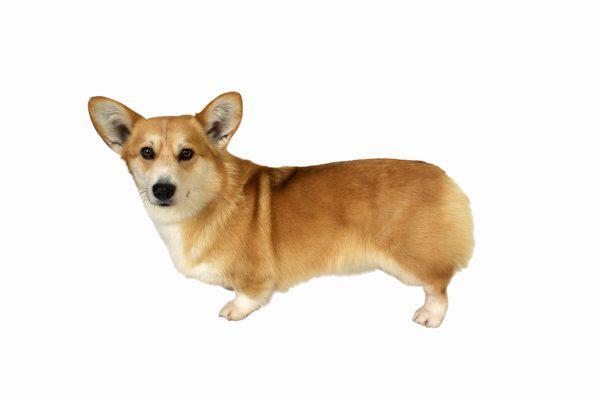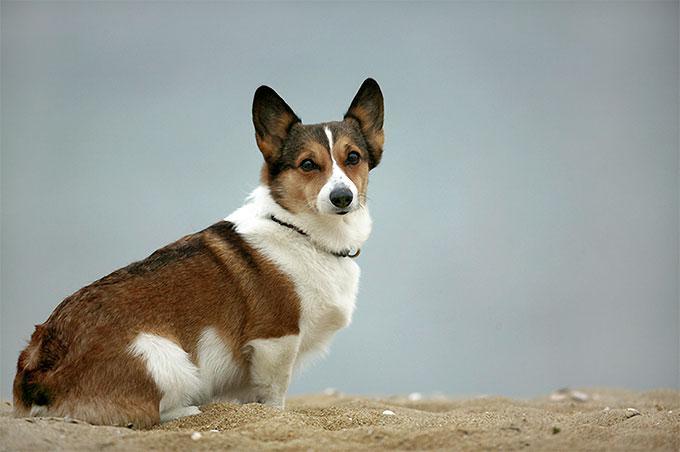The first image is the image on the left, the second image is the image on the right. Examine the images to the left and right. Is the description "The dog in the image on the left is sitting." accurate? Answer yes or no. No. 